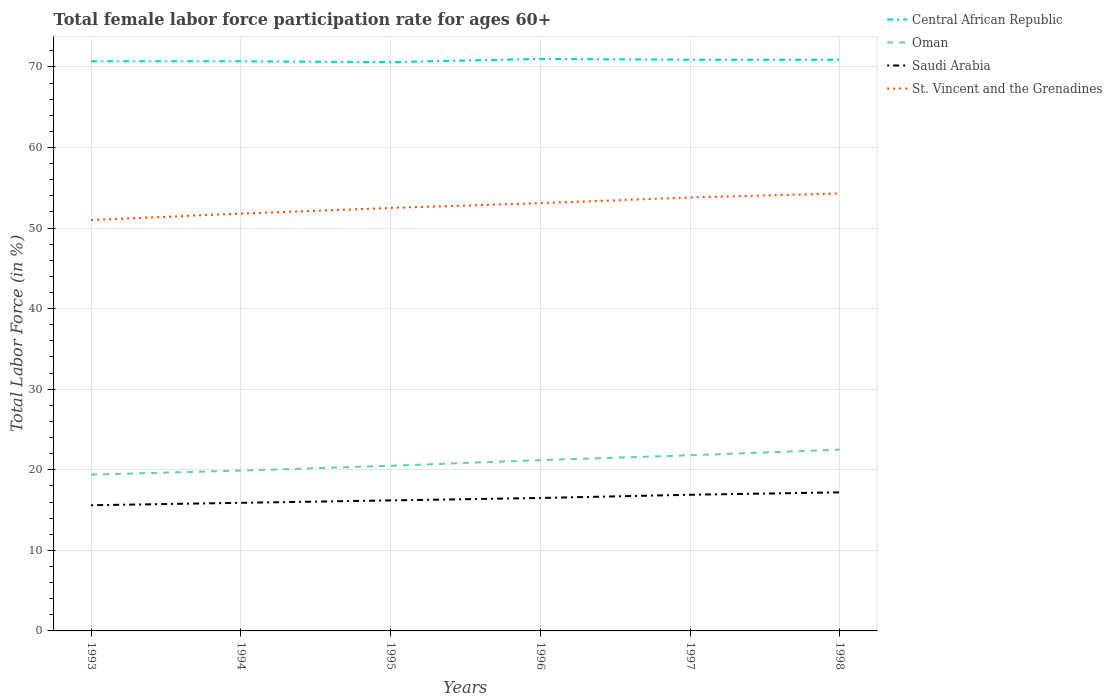Across all years, what is the maximum female labor force participation rate in Central African Republic?
Make the answer very short. 70.6. What is the total female labor force participation rate in Saudi Arabia in the graph?
Make the answer very short. -0.7. What is the difference between the highest and the second highest female labor force participation rate in Oman?
Your response must be concise. 3.1. What is the difference between the highest and the lowest female labor force participation rate in Oman?
Provide a succinct answer. 3. How many lines are there?
Your answer should be very brief. 4. How many years are there in the graph?
Provide a short and direct response. 6. What is the difference between two consecutive major ticks on the Y-axis?
Provide a short and direct response. 10. Are the values on the major ticks of Y-axis written in scientific E-notation?
Your answer should be very brief. No. Does the graph contain any zero values?
Offer a very short reply. No. Where does the legend appear in the graph?
Your answer should be compact. Top right. How many legend labels are there?
Your answer should be compact. 4. What is the title of the graph?
Make the answer very short. Total female labor force participation rate for ages 60+. What is the label or title of the Y-axis?
Provide a short and direct response. Total Labor Force (in %). What is the Total Labor Force (in %) of Central African Republic in 1993?
Your answer should be compact. 70.7. What is the Total Labor Force (in %) in Oman in 1993?
Provide a succinct answer. 19.4. What is the Total Labor Force (in %) of Saudi Arabia in 1993?
Give a very brief answer. 15.6. What is the Total Labor Force (in %) in St. Vincent and the Grenadines in 1993?
Offer a terse response. 51. What is the Total Labor Force (in %) of Central African Republic in 1994?
Your answer should be very brief. 70.7. What is the Total Labor Force (in %) in Oman in 1994?
Offer a very short reply. 19.9. What is the Total Labor Force (in %) of Saudi Arabia in 1994?
Provide a short and direct response. 15.9. What is the Total Labor Force (in %) of St. Vincent and the Grenadines in 1994?
Your answer should be compact. 51.8. What is the Total Labor Force (in %) in Central African Republic in 1995?
Offer a terse response. 70.6. What is the Total Labor Force (in %) in Oman in 1995?
Give a very brief answer. 20.5. What is the Total Labor Force (in %) of Saudi Arabia in 1995?
Offer a very short reply. 16.2. What is the Total Labor Force (in %) of St. Vincent and the Grenadines in 1995?
Provide a succinct answer. 52.5. What is the Total Labor Force (in %) in Oman in 1996?
Your response must be concise. 21.2. What is the Total Labor Force (in %) of Saudi Arabia in 1996?
Ensure brevity in your answer.  16.5. What is the Total Labor Force (in %) of St. Vincent and the Grenadines in 1996?
Your response must be concise. 53.1. What is the Total Labor Force (in %) in Central African Republic in 1997?
Make the answer very short. 70.9. What is the Total Labor Force (in %) in Oman in 1997?
Provide a short and direct response. 21.8. What is the Total Labor Force (in %) in Saudi Arabia in 1997?
Your answer should be compact. 16.9. What is the Total Labor Force (in %) in St. Vincent and the Grenadines in 1997?
Offer a very short reply. 53.8. What is the Total Labor Force (in %) in Central African Republic in 1998?
Provide a short and direct response. 70.9. What is the Total Labor Force (in %) of Saudi Arabia in 1998?
Offer a terse response. 17.2. What is the Total Labor Force (in %) in St. Vincent and the Grenadines in 1998?
Provide a short and direct response. 54.3. Across all years, what is the maximum Total Labor Force (in %) of Saudi Arabia?
Provide a succinct answer. 17.2. Across all years, what is the maximum Total Labor Force (in %) of St. Vincent and the Grenadines?
Make the answer very short. 54.3. Across all years, what is the minimum Total Labor Force (in %) in Central African Republic?
Keep it short and to the point. 70.6. Across all years, what is the minimum Total Labor Force (in %) in Oman?
Provide a succinct answer. 19.4. Across all years, what is the minimum Total Labor Force (in %) of Saudi Arabia?
Your response must be concise. 15.6. What is the total Total Labor Force (in %) in Central African Republic in the graph?
Your answer should be very brief. 424.8. What is the total Total Labor Force (in %) of Oman in the graph?
Keep it short and to the point. 125.3. What is the total Total Labor Force (in %) in Saudi Arabia in the graph?
Ensure brevity in your answer.  98.3. What is the total Total Labor Force (in %) of St. Vincent and the Grenadines in the graph?
Your response must be concise. 316.5. What is the difference between the Total Labor Force (in %) in Oman in 1993 and that in 1994?
Your response must be concise. -0.5. What is the difference between the Total Labor Force (in %) of Central African Republic in 1993 and that in 1995?
Provide a short and direct response. 0.1. What is the difference between the Total Labor Force (in %) in Oman in 1993 and that in 1995?
Your answer should be very brief. -1.1. What is the difference between the Total Labor Force (in %) of Oman in 1993 and that in 1996?
Ensure brevity in your answer.  -1.8. What is the difference between the Total Labor Force (in %) of Saudi Arabia in 1993 and that in 1996?
Your response must be concise. -0.9. What is the difference between the Total Labor Force (in %) in Central African Republic in 1993 and that in 1998?
Provide a succinct answer. -0.2. What is the difference between the Total Labor Force (in %) of Oman in 1993 and that in 1998?
Your response must be concise. -3.1. What is the difference between the Total Labor Force (in %) of St. Vincent and the Grenadines in 1993 and that in 1998?
Your answer should be very brief. -3.3. What is the difference between the Total Labor Force (in %) of Central African Republic in 1994 and that in 1995?
Give a very brief answer. 0.1. What is the difference between the Total Labor Force (in %) of Oman in 1994 and that in 1995?
Offer a very short reply. -0.6. What is the difference between the Total Labor Force (in %) in Oman in 1994 and that in 1996?
Your answer should be very brief. -1.3. What is the difference between the Total Labor Force (in %) of St. Vincent and the Grenadines in 1994 and that in 1996?
Keep it short and to the point. -1.3. What is the difference between the Total Labor Force (in %) in Central African Republic in 1994 and that in 1997?
Your response must be concise. -0.2. What is the difference between the Total Labor Force (in %) in Oman in 1994 and that in 1997?
Your answer should be very brief. -1.9. What is the difference between the Total Labor Force (in %) in Saudi Arabia in 1994 and that in 1997?
Provide a succinct answer. -1. What is the difference between the Total Labor Force (in %) of St. Vincent and the Grenadines in 1994 and that in 1997?
Make the answer very short. -2. What is the difference between the Total Labor Force (in %) in Central African Republic in 1994 and that in 1998?
Offer a terse response. -0.2. What is the difference between the Total Labor Force (in %) in Oman in 1994 and that in 1998?
Offer a terse response. -2.6. What is the difference between the Total Labor Force (in %) in Central African Republic in 1995 and that in 1996?
Offer a very short reply. -0.4. What is the difference between the Total Labor Force (in %) of Oman in 1995 and that in 1996?
Offer a terse response. -0.7. What is the difference between the Total Labor Force (in %) in St. Vincent and the Grenadines in 1995 and that in 1996?
Give a very brief answer. -0.6. What is the difference between the Total Labor Force (in %) in Oman in 1995 and that in 1997?
Your response must be concise. -1.3. What is the difference between the Total Labor Force (in %) of Saudi Arabia in 1995 and that in 1997?
Your response must be concise. -0.7. What is the difference between the Total Labor Force (in %) in St. Vincent and the Grenadines in 1995 and that in 1997?
Your answer should be very brief. -1.3. What is the difference between the Total Labor Force (in %) of St. Vincent and the Grenadines in 1995 and that in 1998?
Offer a terse response. -1.8. What is the difference between the Total Labor Force (in %) of Oman in 1996 and that in 1997?
Provide a succinct answer. -0.6. What is the difference between the Total Labor Force (in %) of St. Vincent and the Grenadines in 1996 and that in 1997?
Your answer should be compact. -0.7. What is the difference between the Total Labor Force (in %) in Central African Republic in 1996 and that in 1998?
Your answer should be very brief. 0.1. What is the difference between the Total Labor Force (in %) in Saudi Arabia in 1996 and that in 1998?
Keep it short and to the point. -0.7. What is the difference between the Total Labor Force (in %) in St. Vincent and the Grenadines in 1996 and that in 1998?
Give a very brief answer. -1.2. What is the difference between the Total Labor Force (in %) in Oman in 1997 and that in 1998?
Ensure brevity in your answer.  -0.7. What is the difference between the Total Labor Force (in %) in Central African Republic in 1993 and the Total Labor Force (in %) in Oman in 1994?
Make the answer very short. 50.8. What is the difference between the Total Labor Force (in %) in Central African Republic in 1993 and the Total Labor Force (in %) in Saudi Arabia in 1994?
Keep it short and to the point. 54.8. What is the difference between the Total Labor Force (in %) of Oman in 1993 and the Total Labor Force (in %) of Saudi Arabia in 1994?
Give a very brief answer. 3.5. What is the difference between the Total Labor Force (in %) in Oman in 1993 and the Total Labor Force (in %) in St. Vincent and the Grenadines in 1994?
Ensure brevity in your answer.  -32.4. What is the difference between the Total Labor Force (in %) of Saudi Arabia in 1993 and the Total Labor Force (in %) of St. Vincent and the Grenadines in 1994?
Provide a short and direct response. -36.2. What is the difference between the Total Labor Force (in %) of Central African Republic in 1993 and the Total Labor Force (in %) of Oman in 1995?
Offer a terse response. 50.2. What is the difference between the Total Labor Force (in %) of Central African Republic in 1993 and the Total Labor Force (in %) of Saudi Arabia in 1995?
Keep it short and to the point. 54.5. What is the difference between the Total Labor Force (in %) in Central African Republic in 1993 and the Total Labor Force (in %) in St. Vincent and the Grenadines in 1995?
Your answer should be very brief. 18.2. What is the difference between the Total Labor Force (in %) in Oman in 1993 and the Total Labor Force (in %) in St. Vincent and the Grenadines in 1995?
Your response must be concise. -33.1. What is the difference between the Total Labor Force (in %) of Saudi Arabia in 1993 and the Total Labor Force (in %) of St. Vincent and the Grenadines in 1995?
Make the answer very short. -36.9. What is the difference between the Total Labor Force (in %) in Central African Republic in 1993 and the Total Labor Force (in %) in Oman in 1996?
Give a very brief answer. 49.5. What is the difference between the Total Labor Force (in %) of Central African Republic in 1993 and the Total Labor Force (in %) of Saudi Arabia in 1996?
Your answer should be compact. 54.2. What is the difference between the Total Labor Force (in %) of Oman in 1993 and the Total Labor Force (in %) of St. Vincent and the Grenadines in 1996?
Your answer should be compact. -33.7. What is the difference between the Total Labor Force (in %) of Saudi Arabia in 1993 and the Total Labor Force (in %) of St. Vincent and the Grenadines in 1996?
Your answer should be compact. -37.5. What is the difference between the Total Labor Force (in %) of Central African Republic in 1993 and the Total Labor Force (in %) of Oman in 1997?
Provide a short and direct response. 48.9. What is the difference between the Total Labor Force (in %) in Central African Republic in 1993 and the Total Labor Force (in %) in Saudi Arabia in 1997?
Ensure brevity in your answer.  53.8. What is the difference between the Total Labor Force (in %) in Oman in 1993 and the Total Labor Force (in %) in Saudi Arabia in 1997?
Keep it short and to the point. 2.5. What is the difference between the Total Labor Force (in %) in Oman in 1993 and the Total Labor Force (in %) in St. Vincent and the Grenadines in 1997?
Give a very brief answer. -34.4. What is the difference between the Total Labor Force (in %) of Saudi Arabia in 1993 and the Total Labor Force (in %) of St. Vincent and the Grenadines in 1997?
Make the answer very short. -38.2. What is the difference between the Total Labor Force (in %) of Central African Republic in 1993 and the Total Labor Force (in %) of Oman in 1998?
Your answer should be compact. 48.2. What is the difference between the Total Labor Force (in %) in Central African Republic in 1993 and the Total Labor Force (in %) in Saudi Arabia in 1998?
Your answer should be very brief. 53.5. What is the difference between the Total Labor Force (in %) of Oman in 1993 and the Total Labor Force (in %) of Saudi Arabia in 1998?
Your answer should be compact. 2.2. What is the difference between the Total Labor Force (in %) of Oman in 1993 and the Total Labor Force (in %) of St. Vincent and the Grenadines in 1998?
Provide a short and direct response. -34.9. What is the difference between the Total Labor Force (in %) in Saudi Arabia in 1993 and the Total Labor Force (in %) in St. Vincent and the Grenadines in 1998?
Keep it short and to the point. -38.7. What is the difference between the Total Labor Force (in %) in Central African Republic in 1994 and the Total Labor Force (in %) in Oman in 1995?
Your answer should be compact. 50.2. What is the difference between the Total Labor Force (in %) of Central African Republic in 1994 and the Total Labor Force (in %) of Saudi Arabia in 1995?
Provide a succinct answer. 54.5. What is the difference between the Total Labor Force (in %) of Central African Republic in 1994 and the Total Labor Force (in %) of St. Vincent and the Grenadines in 1995?
Provide a succinct answer. 18.2. What is the difference between the Total Labor Force (in %) of Oman in 1994 and the Total Labor Force (in %) of Saudi Arabia in 1995?
Your answer should be compact. 3.7. What is the difference between the Total Labor Force (in %) of Oman in 1994 and the Total Labor Force (in %) of St. Vincent and the Grenadines in 1995?
Keep it short and to the point. -32.6. What is the difference between the Total Labor Force (in %) in Saudi Arabia in 1994 and the Total Labor Force (in %) in St. Vincent and the Grenadines in 1995?
Provide a short and direct response. -36.6. What is the difference between the Total Labor Force (in %) in Central African Republic in 1994 and the Total Labor Force (in %) in Oman in 1996?
Give a very brief answer. 49.5. What is the difference between the Total Labor Force (in %) of Central African Republic in 1994 and the Total Labor Force (in %) of Saudi Arabia in 1996?
Provide a short and direct response. 54.2. What is the difference between the Total Labor Force (in %) of Oman in 1994 and the Total Labor Force (in %) of Saudi Arabia in 1996?
Your answer should be compact. 3.4. What is the difference between the Total Labor Force (in %) of Oman in 1994 and the Total Labor Force (in %) of St. Vincent and the Grenadines in 1996?
Offer a very short reply. -33.2. What is the difference between the Total Labor Force (in %) in Saudi Arabia in 1994 and the Total Labor Force (in %) in St. Vincent and the Grenadines in 1996?
Your answer should be compact. -37.2. What is the difference between the Total Labor Force (in %) in Central African Republic in 1994 and the Total Labor Force (in %) in Oman in 1997?
Give a very brief answer. 48.9. What is the difference between the Total Labor Force (in %) of Central African Republic in 1994 and the Total Labor Force (in %) of Saudi Arabia in 1997?
Provide a short and direct response. 53.8. What is the difference between the Total Labor Force (in %) of Central African Republic in 1994 and the Total Labor Force (in %) of St. Vincent and the Grenadines in 1997?
Your answer should be very brief. 16.9. What is the difference between the Total Labor Force (in %) of Oman in 1994 and the Total Labor Force (in %) of Saudi Arabia in 1997?
Your answer should be very brief. 3. What is the difference between the Total Labor Force (in %) in Oman in 1994 and the Total Labor Force (in %) in St. Vincent and the Grenadines in 1997?
Your answer should be compact. -33.9. What is the difference between the Total Labor Force (in %) in Saudi Arabia in 1994 and the Total Labor Force (in %) in St. Vincent and the Grenadines in 1997?
Provide a succinct answer. -37.9. What is the difference between the Total Labor Force (in %) in Central African Republic in 1994 and the Total Labor Force (in %) in Oman in 1998?
Offer a terse response. 48.2. What is the difference between the Total Labor Force (in %) of Central African Republic in 1994 and the Total Labor Force (in %) of Saudi Arabia in 1998?
Make the answer very short. 53.5. What is the difference between the Total Labor Force (in %) of Oman in 1994 and the Total Labor Force (in %) of St. Vincent and the Grenadines in 1998?
Ensure brevity in your answer.  -34.4. What is the difference between the Total Labor Force (in %) of Saudi Arabia in 1994 and the Total Labor Force (in %) of St. Vincent and the Grenadines in 1998?
Offer a terse response. -38.4. What is the difference between the Total Labor Force (in %) in Central African Republic in 1995 and the Total Labor Force (in %) in Oman in 1996?
Provide a succinct answer. 49.4. What is the difference between the Total Labor Force (in %) in Central African Republic in 1995 and the Total Labor Force (in %) in Saudi Arabia in 1996?
Your answer should be compact. 54.1. What is the difference between the Total Labor Force (in %) of Central African Republic in 1995 and the Total Labor Force (in %) of St. Vincent and the Grenadines in 1996?
Ensure brevity in your answer.  17.5. What is the difference between the Total Labor Force (in %) in Oman in 1995 and the Total Labor Force (in %) in Saudi Arabia in 1996?
Provide a succinct answer. 4. What is the difference between the Total Labor Force (in %) in Oman in 1995 and the Total Labor Force (in %) in St. Vincent and the Grenadines in 1996?
Your answer should be very brief. -32.6. What is the difference between the Total Labor Force (in %) of Saudi Arabia in 1995 and the Total Labor Force (in %) of St. Vincent and the Grenadines in 1996?
Make the answer very short. -36.9. What is the difference between the Total Labor Force (in %) of Central African Republic in 1995 and the Total Labor Force (in %) of Oman in 1997?
Offer a terse response. 48.8. What is the difference between the Total Labor Force (in %) in Central African Republic in 1995 and the Total Labor Force (in %) in Saudi Arabia in 1997?
Your response must be concise. 53.7. What is the difference between the Total Labor Force (in %) of Oman in 1995 and the Total Labor Force (in %) of St. Vincent and the Grenadines in 1997?
Keep it short and to the point. -33.3. What is the difference between the Total Labor Force (in %) in Saudi Arabia in 1995 and the Total Labor Force (in %) in St. Vincent and the Grenadines in 1997?
Give a very brief answer. -37.6. What is the difference between the Total Labor Force (in %) of Central African Republic in 1995 and the Total Labor Force (in %) of Oman in 1998?
Make the answer very short. 48.1. What is the difference between the Total Labor Force (in %) in Central African Republic in 1995 and the Total Labor Force (in %) in Saudi Arabia in 1998?
Your response must be concise. 53.4. What is the difference between the Total Labor Force (in %) of Oman in 1995 and the Total Labor Force (in %) of St. Vincent and the Grenadines in 1998?
Your answer should be very brief. -33.8. What is the difference between the Total Labor Force (in %) of Saudi Arabia in 1995 and the Total Labor Force (in %) of St. Vincent and the Grenadines in 1998?
Provide a succinct answer. -38.1. What is the difference between the Total Labor Force (in %) in Central African Republic in 1996 and the Total Labor Force (in %) in Oman in 1997?
Offer a very short reply. 49.2. What is the difference between the Total Labor Force (in %) in Central African Republic in 1996 and the Total Labor Force (in %) in Saudi Arabia in 1997?
Your response must be concise. 54.1. What is the difference between the Total Labor Force (in %) in Oman in 1996 and the Total Labor Force (in %) in Saudi Arabia in 1997?
Your answer should be very brief. 4.3. What is the difference between the Total Labor Force (in %) of Oman in 1996 and the Total Labor Force (in %) of St. Vincent and the Grenadines in 1997?
Your answer should be very brief. -32.6. What is the difference between the Total Labor Force (in %) of Saudi Arabia in 1996 and the Total Labor Force (in %) of St. Vincent and the Grenadines in 1997?
Keep it short and to the point. -37.3. What is the difference between the Total Labor Force (in %) in Central African Republic in 1996 and the Total Labor Force (in %) in Oman in 1998?
Your answer should be very brief. 48.5. What is the difference between the Total Labor Force (in %) of Central African Republic in 1996 and the Total Labor Force (in %) of Saudi Arabia in 1998?
Your answer should be very brief. 53.8. What is the difference between the Total Labor Force (in %) of Oman in 1996 and the Total Labor Force (in %) of Saudi Arabia in 1998?
Your answer should be very brief. 4. What is the difference between the Total Labor Force (in %) in Oman in 1996 and the Total Labor Force (in %) in St. Vincent and the Grenadines in 1998?
Your answer should be very brief. -33.1. What is the difference between the Total Labor Force (in %) of Saudi Arabia in 1996 and the Total Labor Force (in %) of St. Vincent and the Grenadines in 1998?
Give a very brief answer. -37.8. What is the difference between the Total Labor Force (in %) in Central African Republic in 1997 and the Total Labor Force (in %) in Oman in 1998?
Your answer should be very brief. 48.4. What is the difference between the Total Labor Force (in %) in Central African Republic in 1997 and the Total Labor Force (in %) in Saudi Arabia in 1998?
Offer a terse response. 53.7. What is the difference between the Total Labor Force (in %) in Oman in 1997 and the Total Labor Force (in %) in Saudi Arabia in 1998?
Offer a very short reply. 4.6. What is the difference between the Total Labor Force (in %) in Oman in 1997 and the Total Labor Force (in %) in St. Vincent and the Grenadines in 1998?
Provide a short and direct response. -32.5. What is the difference between the Total Labor Force (in %) in Saudi Arabia in 1997 and the Total Labor Force (in %) in St. Vincent and the Grenadines in 1998?
Make the answer very short. -37.4. What is the average Total Labor Force (in %) of Central African Republic per year?
Your answer should be compact. 70.8. What is the average Total Labor Force (in %) of Oman per year?
Ensure brevity in your answer.  20.88. What is the average Total Labor Force (in %) of Saudi Arabia per year?
Ensure brevity in your answer.  16.38. What is the average Total Labor Force (in %) of St. Vincent and the Grenadines per year?
Provide a short and direct response. 52.75. In the year 1993, what is the difference between the Total Labor Force (in %) in Central African Republic and Total Labor Force (in %) in Oman?
Keep it short and to the point. 51.3. In the year 1993, what is the difference between the Total Labor Force (in %) in Central African Republic and Total Labor Force (in %) in Saudi Arabia?
Ensure brevity in your answer.  55.1. In the year 1993, what is the difference between the Total Labor Force (in %) in Central African Republic and Total Labor Force (in %) in St. Vincent and the Grenadines?
Provide a succinct answer. 19.7. In the year 1993, what is the difference between the Total Labor Force (in %) in Oman and Total Labor Force (in %) in St. Vincent and the Grenadines?
Ensure brevity in your answer.  -31.6. In the year 1993, what is the difference between the Total Labor Force (in %) in Saudi Arabia and Total Labor Force (in %) in St. Vincent and the Grenadines?
Offer a very short reply. -35.4. In the year 1994, what is the difference between the Total Labor Force (in %) in Central African Republic and Total Labor Force (in %) in Oman?
Offer a terse response. 50.8. In the year 1994, what is the difference between the Total Labor Force (in %) in Central African Republic and Total Labor Force (in %) in Saudi Arabia?
Offer a very short reply. 54.8. In the year 1994, what is the difference between the Total Labor Force (in %) of Oman and Total Labor Force (in %) of St. Vincent and the Grenadines?
Your answer should be very brief. -31.9. In the year 1994, what is the difference between the Total Labor Force (in %) in Saudi Arabia and Total Labor Force (in %) in St. Vincent and the Grenadines?
Provide a short and direct response. -35.9. In the year 1995, what is the difference between the Total Labor Force (in %) in Central African Republic and Total Labor Force (in %) in Oman?
Ensure brevity in your answer.  50.1. In the year 1995, what is the difference between the Total Labor Force (in %) of Central African Republic and Total Labor Force (in %) of Saudi Arabia?
Keep it short and to the point. 54.4. In the year 1995, what is the difference between the Total Labor Force (in %) in Oman and Total Labor Force (in %) in St. Vincent and the Grenadines?
Ensure brevity in your answer.  -32. In the year 1995, what is the difference between the Total Labor Force (in %) of Saudi Arabia and Total Labor Force (in %) of St. Vincent and the Grenadines?
Give a very brief answer. -36.3. In the year 1996, what is the difference between the Total Labor Force (in %) of Central African Republic and Total Labor Force (in %) of Oman?
Make the answer very short. 49.8. In the year 1996, what is the difference between the Total Labor Force (in %) in Central African Republic and Total Labor Force (in %) in Saudi Arabia?
Provide a short and direct response. 54.5. In the year 1996, what is the difference between the Total Labor Force (in %) of Central African Republic and Total Labor Force (in %) of St. Vincent and the Grenadines?
Your response must be concise. 17.9. In the year 1996, what is the difference between the Total Labor Force (in %) in Oman and Total Labor Force (in %) in Saudi Arabia?
Provide a succinct answer. 4.7. In the year 1996, what is the difference between the Total Labor Force (in %) of Oman and Total Labor Force (in %) of St. Vincent and the Grenadines?
Keep it short and to the point. -31.9. In the year 1996, what is the difference between the Total Labor Force (in %) in Saudi Arabia and Total Labor Force (in %) in St. Vincent and the Grenadines?
Your answer should be very brief. -36.6. In the year 1997, what is the difference between the Total Labor Force (in %) of Central African Republic and Total Labor Force (in %) of Oman?
Give a very brief answer. 49.1. In the year 1997, what is the difference between the Total Labor Force (in %) of Oman and Total Labor Force (in %) of St. Vincent and the Grenadines?
Keep it short and to the point. -32. In the year 1997, what is the difference between the Total Labor Force (in %) of Saudi Arabia and Total Labor Force (in %) of St. Vincent and the Grenadines?
Give a very brief answer. -36.9. In the year 1998, what is the difference between the Total Labor Force (in %) of Central African Republic and Total Labor Force (in %) of Oman?
Your answer should be compact. 48.4. In the year 1998, what is the difference between the Total Labor Force (in %) in Central African Republic and Total Labor Force (in %) in Saudi Arabia?
Your answer should be compact. 53.7. In the year 1998, what is the difference between the Total Labor Force (in %) in Central African Republic and Total Labor Force (in %) in St. Vincent and the Grenadines?
Your answer should be compact. 16.6. In the year 1998, what is the difference between the Total Labor Force (in %) in Oman and Total Labor Force (in %) in St. Vincent and the Grenadines?
Make the answer very short. -31.8. In the year 1998, what is the difference between the Total Labor Force (in %) in Saudi Arabia and Total Labor Force (in %) in St. Vincent and the Grenadines?
Offer a very short reply. -37.1. What is the ratio of the Total Labor Force (in %) in Central African Republic in 1993 to that in 1994?
Provide a succinct answer. 1. What is the ratio of the Total Labor Force (in %) of Oman in 1993 to that in 1994?
Ensure brevity in your answer.  0.97. What is the ratio of the Total Labor Force (in %) in Saudi Arabia in 1993 to that in 1994?
Offer a terse response. 0.98. What is the ratio of the Total Labor Force (in %) in St. Vincent and the Grenadines in 1993 to that in 1994?
Ensure brevity in your answer.  0.98. What is the ratio of the Total Labor Force (in %) of Oman in 1993 to that in 1995?
Make the answer very short. 0.95. What is the ratio of the Total Labor Force (in %) of Saudi Arabia in 1993 to that in 1995?
Your response must be concise. 0.96. What is the ratio of the Total Labor Force (in %) of St. Vincent and the Grenadines in 1993 to that in 1995?
Keep it short and to the point. 0.97. What is the ratio of the Total Labor Force (in %) of Oman in 1993 to that in 1996?
Ensure brevity in your answer.  0.92. What is the ratio of the Total Labor Force (in %) in Saudi Arabia in 1993 to that in 1996?
Your response must be concise. 0.95. What is the ratio of the Total Labor Force (in %) of St. Vincent and the Grenadines in 1993 to that in 1996?
Make the answer very short. 0.96. What is the ratio of the Total Labor Force (in %) in Central African Republic in 1993 to that in 1997?
Provide a succinct answer. 1. What is the ratio of the Total Labor Force (in %) of Oman in 1993 to that in 1997?
Make the answer very short. 0.89. What is the ratio of the Total Labor Force (in %) in Saudi Arabia in 1993 to that in 1997?
Provide a short and direct response. 0.92. What is the ratio of the Total Labor Force (in %) of St. Vincent and the Grenadines in 1993 to that in 1997?
Offer a terse response. 0.95. What is the ratio of the Total Labor Force (in %) in Central African Republic in 1993 to that in 1998?
Provide a succinct answer. 1. What is the ratio of the Total Labor Force (in %) in Oman in 1993 to that in 1998?
Ensure brevity in your answer.  0.86. What is the ratio of the Total Labor Force (in %) of Saudi Arabia in 1993 to that in 1998?
Give a very brief answer. 0.91. What is the ratio of the Total Labor Force (in %) in St. Vincent and the Grenadines in 1993 to that in 1998?
Provide a succinct answer. 0.94. What is the ratio of the Total Labor Force (in %) in Central African Republic in 1994 to that in 1995?
Provide a short and direct response. 1. What is the ratio of the Total Labor Force (in %) in Oman in 1994 to that in 1995?
Your answer should be compact. 0.97. What is the ratio of the Total Labor Force (in %) in Saudi Arabia in 1994 to that in 1995?
Provide a short and direct response. 0.98. What is the ratio of the Total Labor Force (in %) in St. Vincent and the Grenadines in 1994 to that in 1995?
Provide a short and direct response. 0.99. What is the ratio of the Total Labor Force (in %) in Central African Republic in 1994 to that in 1996?
Offer a terse response. 1. What is the ratio of the Total Labor Force (in %) in Oman in 1994 to that in 1996?
Your answer should be very brief. 0.94. What is the ratio of the Total Labor Force (in %) of Saudi Arabia in 1994 to that in 1996?
Your answer should be very brief. 0.96. What is the ratio of the Total Labor Force (in %) of St. Vincent and the Grenadines in 1994 to that in 1996?
Provide a succinct answer. 0.98. What is the ratio of the Total Labor Force (in %) of Oman in 1994 to that in 1997?
Keep it short and to the point. 0.91. What is the ratio of the Total Labor Force (in %) in Saudi Arabia in 1994 to that in 1997?
Ensure brevity in your answer.  0.94. What is the ratio of the Total Labor Force (in %) of St. Vincent and the Grenadines in 1994 to that in 1997?
Make the answer very short. 0.96. What is the ratio of the Total Labor Force (in %) of Central African Republic in 1994 to that in 1998?
Your answer should be compact. 1. What is the ratio of the Total Labor Force (in %) in Oman in 1994 to that in 1998?
Offer a terse response. 0.88. What is the ratio of the Total Labor Force (in %) of Saudi Arabia in 1994 to that in 1998?
Provide a short and direct response. 0.92. What is the ratio of the Total Labor Force (in %) of St. Vincent and the Grenadines in 1994 to that in 1998?
Offer a terse response. 0.95. What is the ratio of the Total Labor Force (in %) in Central African Republic in 1995 to that in 1996?
Your response must be concise. 0.99. What is the ratio of the Total Labor Force (in %) in Oman in 1995 to that in 1996?
Make the answer very short. 0.97. What is the ratio of the Total Labor Force (in %) of Saudi Arabia in 1995 to that in 1996?
Your answer should be compact. 0.98. What is the ratio of the Total Labor Force (in %) of St. Vincent and the Grenadines in 1995 to that in 1996?
Provide a short and direct response. 0.99. What is the ratio of the Total Labor Force (in %) in Central African Republic in 1995 to that in 1997?
Your answer should be very brief. 1. What is the ratio of the Total Labor Force (in %) in Oman in 1995 to that in 1997?
Provide a succinct answer. 0.94. What is the ratio of the Total Labor Force (in %) of Saudi Arabia in 1995 to that in 1997?
Your answer should be compact. 0.96. What is the ratio of the Total Labor Force (in %) of St. Vincent and the Grenadines in 1995 to that in 1997?
Your answer should be very brief. 0.98. What is the ratio of the Total Labor Force (in %) of Oman in 1995 to that in 1998?
Ensure brevity in your answer.  0.91. What is the ratio of the Total Labor Force (in %) of Saudi Arabia in 1995 to that in 1998?
Your response must be concise. 0.94. What is the ratio of the Total Labor Force (in %) of St. Vincent and the Grenadines in 1995 to that in 1998?
Offer a terse response. 0.97. What is the ratio of the Total Labor Force (in %) of Oman in 1996 to that in 1997?
Keep it short and to the point. 0.97. What is the ratio of the Total Labor Force (in %) in Saudi Arabia in 1996 to that in 1997?
Keep it short and to the point. 0.98. What is the ratio of the Total Labor Force (in %) of St. Vincent and the Grenadines in 1996 to that in 1997?
Give a very brief answer. 0.99. What is the ratio of the Total Labor Force (in %) of Oman in 1996 to that in 1998?
Offer a very short reply. 0.94. What is the ratio of the Total Labor Force (in %) in Saudi Arabia in 1996 to that in 1998?
Provide a succinct answer. 0.96. What is the ratio of the Total Labor Force (in %) in St. Vincent and the Grenadines in 1996 to that in 1998?
Your answer should be compact. 0.98. What is the ratio of the Total Labor Force (in %) in Central African Republic in 1997 to that in 1998?
Ensure brevity in your answer.  1. What is the ratio of the Total Labor Force (in %) of Oman in 1997 to that in 1998?
Offer a terse response. 0.97. What is the ratio of the Total Labor Force (in %) in Saudi Arabia in 1997 to that in 1998?
Your answer should be compact. 0.98. What is the ratio of the Total Labor Force (in %) of St. Vincent and the Grenadines in 1997 to that in 1998?
Give a very brief answer. 0.99. What is the difference between the highest and the second highest Total Labor Force (in %) in Central African Republic?
Offer a very short reply. 0.1. What is the difference between the highest and the second highest Total Labor Force (in %) in Oman?
Your answer should be compact. 0.7. What is the difference between the highest and the second highest Total Labor Force (in %) of Saudi Arabia?
Your answer should be very brief. 0.3. What is the difference between the highest and the lowest Total Labor Force (in %) in Central African Republic?
Offer a very short reply. 0.4. What is the difference between the highest and the lowest Total Labor Force (in %) in Oman?
Your answer should be compact. 3.1. What is the difference between the highest and the lowest Total Labor Force (in %) of St. Vincent and the Grenadines?
Make the answer very short. 3.3. 